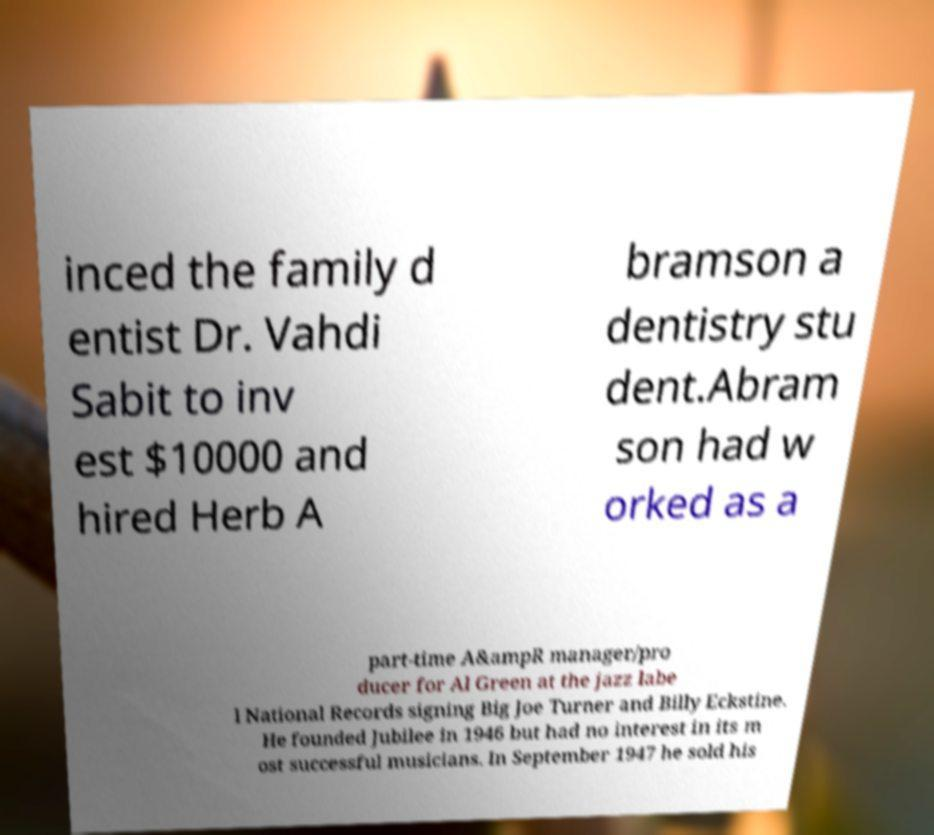Please identify and transcribe the text found in this image. inced the family d entist Dr. Vahdi Sabit to inv est $10000 and hired Herb A bramson a dentistry stu dent.Abram son had w orked as a part-time A&ampR manager/pro ducer for Al Green at the jazz labe l National Records signing Big Joe Turner and Billy Eckstine. He founded Jubilee in 1946 but had no interest in its m ost successful musicians. In September 1947 he sold his 